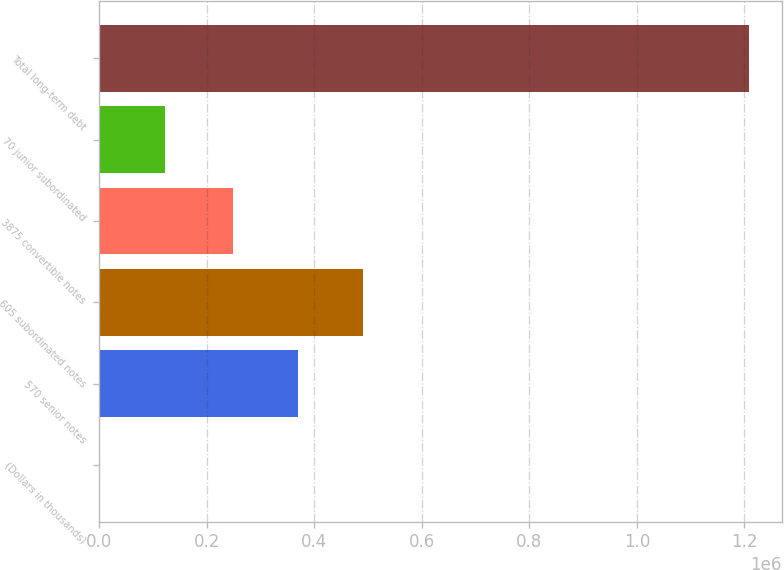<chart> <loc_0><loc_0><loc_500><loc_500><bar_chart><fcel>(Dollars in thousands)<fcel>570 senior notes<fcel>605 subordinated notes<fcel>3875 convertible notes<fcel>70 junior subordinated<fcel>Total long-term debt<nl><fcel>2010<fcel>370029<fcel>490754<fcel>249304<fcel>122735<fcel>1.20926e+06<nl></chart> 